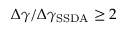<formula> <loc_0><loc_0><loc_500><loc_500>\Delta \gamma / \Delta \gamma _ { S S D A } \geq 2</formula> 